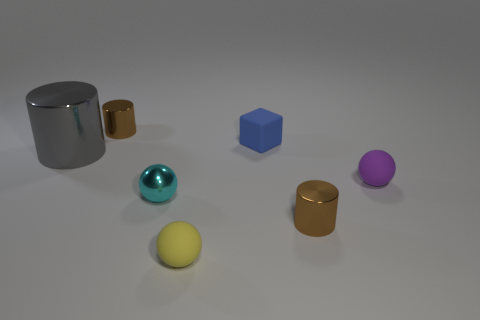Can you describe the arrangement of objects in terms of their proximity to each other? Certainly! The objects are arranged on a flat surface in a somewhat scattered manner. The large reflective cylinder stands alone on the left, while two smaller cylinders and the teal reflective sphere are grouped closer together on the right. The yellow and purple spheres are isolated from the other objects. The reflective teal sphere is closest to the camera. 